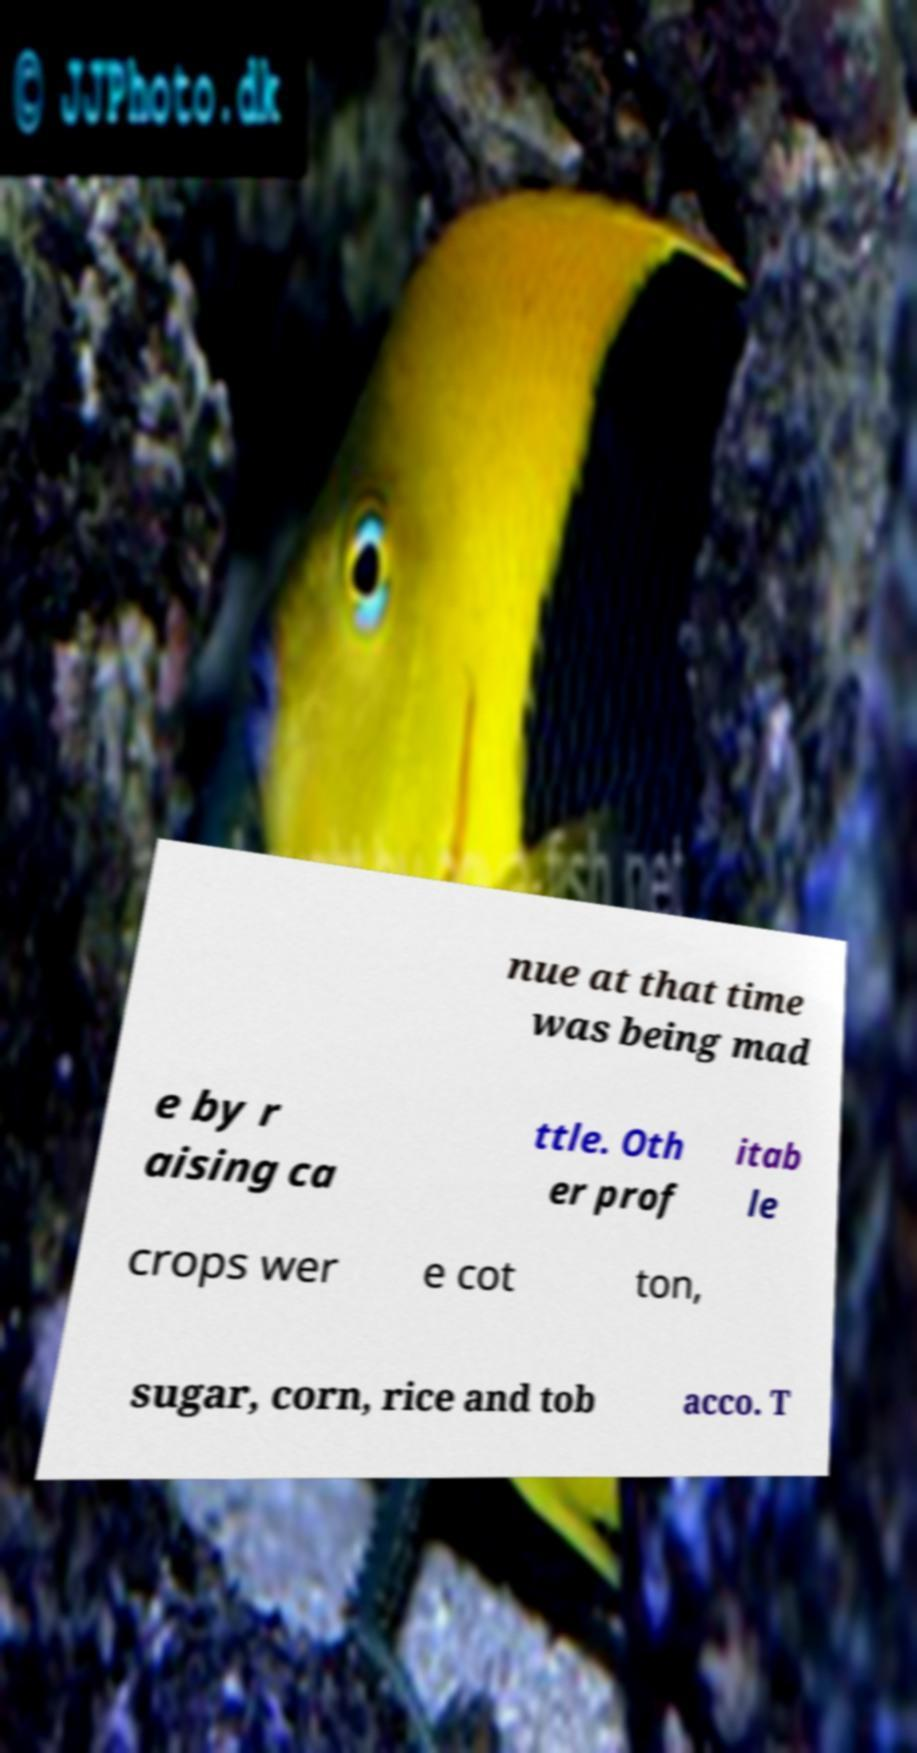Could you extract and type out the text from this image? nue at that time was being mad e by r aising ca ttle. Oth er prof itab le crops wer e cot ton, sugar, corn, rice and tob acco. T 